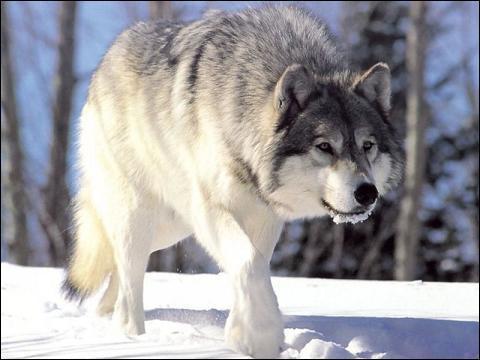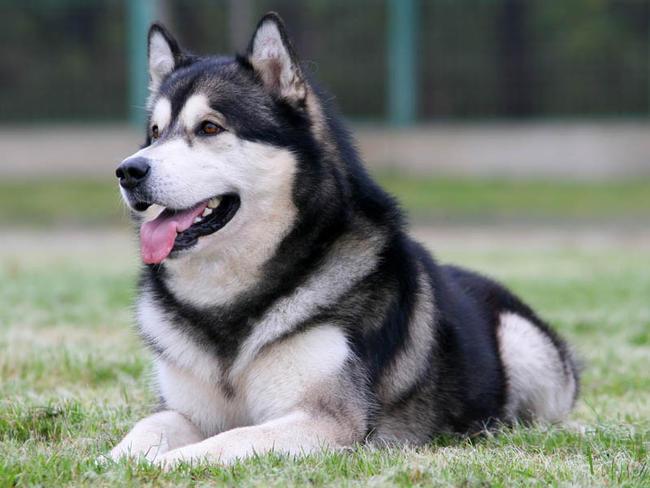The first image is the image on the left, the second image is the image on the right. Evaluate the accuracy of this statement regarding the images: "In one image, four dogs are sitting in a group, while a single dog is in a second image.". Is it true? Answer yes or no. No. The first image is the image on the left, the second image is the image on the right. Analyze the images presented: Is the assertion "In the image on the left, four Malamutes are sitting in the grass in front of a shelter and looking up at something." valid? Answer yes or no. No. 